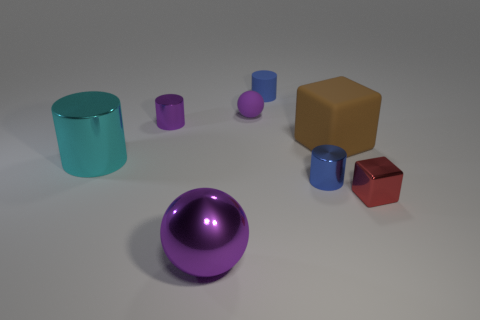Subtract 1 cylinders. How many cylinders are left? 3 Add 2 purple metallic spheres. How many objects exist? 10 Subtract all cubes. How many objects are left? 6 Subtract all blue matte objects. Subtract all small cylinders. How many objects are left? 4 Add 7 brown rubber objects. How many brown rubber objects are left? 8 Add 2 green matte things. How many green matte things exist? 2 Subtract 0 blue blocks. How many objects are left? 8 